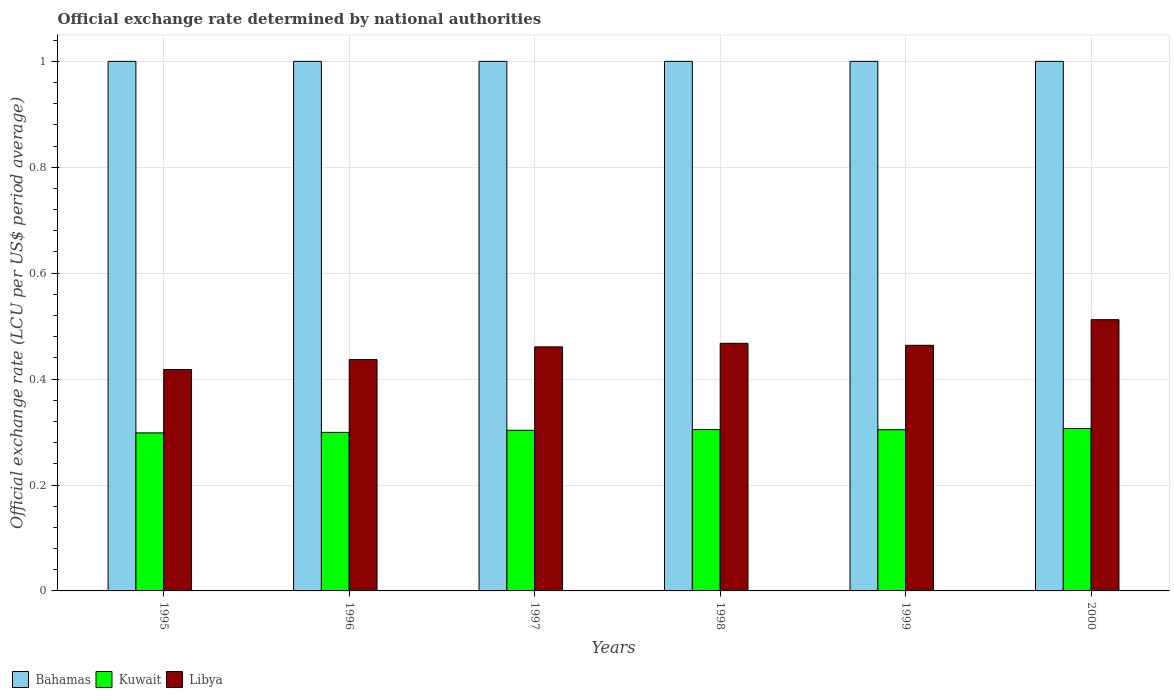Are the number of bars per tick equal to the number of legend labels?
Offer a terse response. Yes. Are the number of bars on each tick of the X-axis equal?
Give a very brief answer. Yes. How many bars are there on the 5th tick from the right?
Give a very brief answer. 3. What is the official exchange rate in Libya in 2000?
Provide a succinct answer. 0.51. Across all years, what is the minimum official exchange rate in Bahamas?
Your answer should be compact. 1. In which year was the official exchange rate in Libya maximum?
Offer a very short reply. 2000. What is the total official exchange rate in Libya in the graph?
Offer a very short reply. 2.76. What is the difference between the official exchange rate in Libya in 1995 and that in 1997?
Keep it short and to the point. -0.04. What is the difference between the official exchange rate in Bahamas in 1998 and the official exchange rate in Kuwait in 1995?
Your answer should be very brief. 0.7. What is the average official exchange rate in Kuwait per year?
Make the answer very short. 0.3. In the year 2000, what is the difference between the official exchange rate in Libya and official exchange rate in Bahamas?
Make the answer very short. -0.49. What is the ratio of the official exchange rate in Kuwait in 1998 to that in 1999?
Your response must be concise. 1. What is the difference between the highest and the second highest official exchange rate in Kuwait?
Offer a very short reply. 0. What is the difference between the highest and the lowest official exchange rate in Kuwait?
Provide a short and direct response. 0.01. Is the sum of the official exchange rate in Kuwait in 1997 and 2000 greater than the maximum official exchange rate in Bahamas across all years?
Provide a short and direct response. No. What does the 2nd bar from the left in 1995 represents?
Ensure brevity in your answer.  Kuwait. What does the 2nd bar from the right in 1995 represents?
Your response must be concise. Kuwait. Is it the case that in every year, the sum of the official exchange rate in Kuwait and official exchange rate in Libya is greater than the official exchange rate in Bahamas?
Your answer should be very brief. No. How many bars are there?
Your response must be concise. 18. Does the graph contain any zero values?
Your answer should be compact. No. How many legend labels are there?
Provide a short and direct response. 3. How are the legend labels stacked?
Your response must be concise. Horizontal. What is the title of the graph?
Your response must be concise. Official exchange rate determined by national authorities. Does "Gabon" appear as one of the legend labels in the graph?
Make the answer very short. No. What is the label or title of the X-axis?
Make the answer very short. Years. What is the label or title of the Y-axis?
Provide a short and direct response. Official exchange rate (LCU per US$ period average). What is the Official exchange rate (LCU per US$ period average) of Bahamas in 1995?
Provide a succinct answer. 1. What is the Official exchange rate (LCU per US$ period average) of Kuwait in 1995?
Ensure brevity in your answer.  0.3. What is the Official exchange rate (LCU per US$ period average) of Libya in 1995?
Give a very brief answer. 0.42. What is the Official exchange rate (LCU per US$ period average) of Bahamas in 1996?
Provide a short and direct response. 1. What is the Official exchange rate (LCU per US$ period average) of Kuwait in 1996?
Provide a succinct answer. 0.3. What is the Official exchange rate (LCU per US$ period average) in Libya in 1996?
Make the answer very short. 0.44. What is the Official exchange rate (LCU per US$ period average) in Bahamas in 1997?
Make the answer very short. 1. What is the Official exchange rate (LCU per US$ period average) of Kuwait in 1997?
Your answer should be very brief. 0.3. What is the Official exchange rate (LCU per US$ period average) in Libya in 1997?
Your answer should be compact. 0.46. What is the Official exchange rate (LCU per US$ period average) of Bahamas in 1998?
Offer a terse response. 1. What is the Official exchange rate (LCU per US$ period average) in Kuwait in 1998?
Provide a short and direct response. 0.3. What is the Official exchange rate (LCU per US$ period average) of Libya in 1998?
Provide a short and direct response. 0.47. What is the Official exchange rate (LCU per US$ period average) of Bahamas in 1999?
Provide a succinct answer. 1. What is the Official exchange rate (LCU per US$ period average) of Kuwait in 1999?
Your response must be concise. 0.3. What is the Official exchange rate (LCU per US$ period average) in Libya in 1999?
Keep it short and to the point. 0.46. What is the Official exchange rate (LCU per US$ period average) of Kuwait in 2000?
Provide a succinct answer. 0.31. What is the Official exchange rate (LCU per US$ period average) in Libya in 2000?
Make the answer very short. 0.51. Across all years, what is the maximum Official exchange rate (LCU per US$ period average) in Bahamas?
Keep it short and to the point. 1. Across all years, what is the maximum Official exchange rate (LCU per US$ period average) of Kuwait?
Your answer should be very brief. 0.31. Across all years, what is the maximum Official exchange rate (LCU per US$ period average) of Libya?
Your answer should be compact. 0.51. Across all years, what is the minimum Official exchange rate (LCU per US$ period average) of Kuwait?
Your response must be concise. 0.3. Across all years, what is the minimum Official exchange rate (LCU per US$ period average) in Libya?
Your answer should be compact. 0.42. What is the total Official exchange rate (LCU per US$ period average) in Kuwait in the graph?
Your response must be concise. 1.82. What is the total Official exchange rate (LCU per US$ period average) of Libya in the graph?
Provide a short and direct response. 2.76. What is the difference between the Official exchange rate (LCU per US$ period average) of Bahamas in 1995 and that in 1996?
Offer a terse response. 0. What is the difference between the Official exchange rate (LCU per US$ period average) in Kuwait in 1995 and that in 1996?
Offer a very short reply. -0. What is the difference between the Official exchange rate (LCU per US$ period average) in Libya in 1995 and that in 1996?
Your response must be concise. -0.02. What is the difference between the Official exchange rate (LCU per US$ period average) of Bahamas in 1995 and that in 1997?
Keep it short and to the point. 0. What is the difference between the Official exchange rate (LCU per US$ period average) of Kuwait in 1995 and that in 1997?
Offer a very short reply. -0. What is the difference between the Official exchange rate (LCU per US$ period average) of Libya in 1995 and that in 1997?
Make the answer very short. -0.04. What is the difference between the Official exchange rate (LCU per US$ period average) of Bahamas in 1995 and that in 1998?
Your response must be concise. 0. What is the difference between the Official exchange rate (LCU per US$ period average) of Kuwait in 1995 and that in 1998?
Ensure brevity in your answer.  -0.01. What is the difference between the Official exchange rate (LCU per US$ period average) in Libya in 1995 and that in 1998?
Make the answer very short. -0.05. What is the difference between the Official exchange rate (LCU per US$ period average) in Bahamas in 1995 and that in 1999?
Give a very brief answer. 0. What is the difference between the Official exchange rate (LCU per US$ period average) of Kuwait in 1995 and that in 1999?
Provide a short and direct response. -0.01. What is the difference between the Official exchange rate (LCU per US$ period average) of Libya in 1995 and that in 1999?
Ensure brevity in your answer.  -0.05. What is the difference between the Official exchange rate (LCU per US$ period average) in Bahamas in 1995 and that in 2000?
Provide a succinct answer. 0. What is the difference between the Official exchange rate (LCU per US$ period average) of Kuwait in 1995 and that in 2000?
Your answer should be compact. -0.01. What is the difference between the Official exchange rate (LCU per US$ period average) of Libya in 1995 and that in 2000?
Your response must be concise. -0.09. What is the difference between the Official exchange rate (LCU per US$ period average) of Bahamas in 1996 and that in 1997?
Offer a terse response. 0. What is the difference between the Official exchange rate (LCU per US$ period average) of Kuwait in 1996 and that in 1997?
Your response must be concise. -0. What is the difference between the Official exchange rate (LCU per US$ period average) in Libya in 1996 and that in 1997?
Give a very brief answer. -0.02. What is the difference between the Official exchange rate (LCU per US$ period average) in Bahamas in 1996 and that in 1998?
Give a very brief answer. 0. What is the difference between the Official exchange rate (LCU per US$ period average) of Kuwait in 1996 and that in 1998?
Your answer should be compact. -0.01. What is the difference between the Official exchange rate (LCU per US$ period average) of Libya in 1996 and that in 1998?
Provide a short and direct response. -0.03. What is the difference between the Official exchange rate (LCU per US$ period average) of Kuwait in 1996 and that in 1999?
Your answer should be very brief. -0.01. What is the difference between the Official exchange rate (LCU per US$ period average) in Libya in 1996 and that in 1999?
Keep it short and to the point. -0.03. What is the difference between the Official exchange rate (LCU per US$ period average) of Bahamas in 1996 and that in 2000?
Offer a terse response. 0. What is the difference between the Official exchange rate (LCU per US$ period average) of Kuwait in 1996 and that in 2000?
Ensure brevity in your answer.  -0.01. What is the difference between the Official exchange rate (LCU per US$ period average) of Libya in 1996 and that in 2000?
Provide a succinct answer. -0.08. What is the difference between the Official exchange rate (LCU per US$ period average) in Bahamas in 1997 and that in 1998?
Offer a terse response. 0. What is the difference between the Official exchange rate (LCU per US$ period average) of Kuwait in 1997 and that in 1998?
Ensure brevity in your answer.  -0. What is the difference between the Official exchange rate (LCU per US$ period average) in Libya in 1997 and that in 1998?
Your response must be concise. -0.01. What is the difference between the Official exchange rate (LCU per US$ period average) of Kuwait in 1997 and that in 1999?
Your response must be concise. -0. What is the difference between the Official exchange rate (LCU per US$ period average) of Libya in 1997 and that in 1999?
Your response must be concise. -0. What is the difference between the Official exchange rate (LCU per US$ period average) of Bahamas in 1997 and that in 2000?
Your response must be concise. 0. What is the difference between the Official exchange rate (LCU per US$ period average) of Kuwait in 1997 and that in 2000?
Ensure brevity in your answer.  -0. What is the difference between the Official exchange rate (LCU per US$ period average) of Libya in 1997 and that in 2000?
Provide a succinct answer. -0.05. What is the difference between the Official exchange rate (LCU per US$ period average) of Kuwait in 1998 and that in 1999?
Provide a short and direct response. 0. What is the difference between the Official exchange rate (LCU per US$ period average) of Libya in 1998 and that in 1999?
Offer a terse response. 0. What is the difference between the Official exchange rate (LCU per US$ period average) of Bahamas in 1998 and that in 2000?
Provide a short and direct response. 0. What is the difference between the Official exchange rate (LCU per US$ period average) in Kuwait in 1998 and that in 2000?
Your answer should be compact. -0. What is the difference between the Official exchange rate (LCU per US$ period average) in Libya in 1998 and that in 2000?
Offer a terse response. -0.04. What is the difference between the Official exchange rate (LCU per US$ period average) in Bahamas in 1999 and that in 2000?
Give a very brief answer. 0. What is the difference between the Official exchange rate (LCU per US$ period average) of Kuwait in 1999 and that in 2000?
Offer a very short reply. -0. What is the difference between the Official exchange rate (LCU per US$ period average) of Libya in 1999 and that in 2000?
Your answer should be very brief. -0.05. What is the difference between the Official exchange rate (LCU per US$ period average) of Bahamas in 1995 and the Official exchange rate (LCU per US$ period average) of Kuwait in 1996?
Provide a succinct answer. 0.7. What is the difference between the Official exchange rate (LCU per US$ period average) in Bahamas in 1995 and the Official exchange rate (LCU per US$ period average) in Libya in 1996?
Your response must be concise. 0.56. What is the difference between the Official exchange rate (LCU per US$ period average) of Kuwait in 1995 and the Official exchange rate (LCU per US$ period average) of Libya in 1996?
Your answer should be very brief. -0.14. What is the difference between the Official exchange rate (LCU per US$ period average) in Bahamas in 1995 and the Official exchange rate (LCU per US$ period average) in Kuwait in 1997?
Your answer should be compact. 0.7. What is the difference between the Official exchange rate (LCU per US$ period average) in Bahamas in 1995 and the Official exchange rate (LCU per US$ period average) in Libya in 1997?
Make the answer very short. 0.54. What is the difference between the Official exchange rate (LCU per US$ period average) of Kuwait in 1995 and the Official exchange rate (LCU per US$ period average) of Libya in 1997?
Provide a succinct answer. -0.16. What is the difference between the Official exchange rate (LCU per US$ period average) in Bahamas in 1995 and the Official exchange rate (LCU per US$ period average) in Kuwait in 1998?
Keep it short and to the point. 0.7. What is the difference between the Official exchange rate (LCU per US$ period average) of Bahamas in 1995 and the Official exchange rate (LCU per US$ period average) of Libya in 1998?
Provide a short and direct response. 0.53. What is the difference between the Official exchange rate (LCU per US$ period average) of Kuwait in 1995 and the Official exchange rate (LCU per US$ period average) of Libya in 1998?
Provide a short and direct response. -0.17. What is the difference between the Official exchange rate (LCU per US$ period average) of Bahamas in 1995 and the Official exchange rate (LCU per US$ period average) of Kuwait in 1999?
Provide a succinct answer. 0.7. What is the difference between the Official exchange rate (LCU per US$ period average) in Bahamas in 1995 and the Official exchange rate (LCU per US$ period average) in Libya in 1999?
Offer a very short reply. 0.54. What is the difference between the Official exchange rate (LCU per US$ period average) of Kuwait in 1995 and the Official exchange rate (LCU per US$ period average) of Libya in 1999?
Ensure brevity in your answer.  -0.17. What is the difference between the Official exchange rate (LCU per US$ period average) of Bahamas in 1995 and the Official exchange rate (LCU per US$ period average) of Kuwait in 2000?
Provide a short and direct response. 0.69. What is the difference between the Official exchange rate (LCU per US$ period average) of Bahamas in 1995 and the Official exchange rate (LCU per US$ period average) of Libya in 2000?
Give a very brief answer. 0.49. What is the difference between the Official exchange rate (LCU per US$ period average) in Kuwait in 1995 and the Official exchange rate (LCU per US$ period average) in Libya in 2000?
Provide a succinct answer. -0.21. What is the difference between the Official exchange rate (LCU per US$ period average) of Bahamas in 1996 and the Official exchange rate (LCU per US$ period average) of Kuwait in 1997?
Make the answer very short. 0.7. What is the difference between the Official exchange rate (LCU per US$ period average) of Bahamas in 1996 and the Official exchange rate (LCU per US$ period average) of Libya in 1997?
Offer a terse response. 0.54. What is the difference between the Official exchange rate (LCU per US$ period average) in Kuwait in 1996 and the Official exchange rate (LCU per US$ period average) in Libya in 1997?
Your answer should be compact. -0.16. What is the difference between the Official exchange rate (LCU per US$ period average) in Bahamas in 1996 and the Official exchange rate (LCU per US$ period average) in Kuwait in 1998?
Your response must be concise. 0.7. What is the difference between the Official exchange rate (LCU per US$ period average) of Bahamas in 1996 and the Official exchange rate (LCU per US$ period average) of Libya in 1998?
Provide a succinct answer. 0.53. What is the difference between the Official exchange rate (LCU per US$ period average) in Kuwait in 1996 and the Official exchange rate (LCU per US$ period average) in Libya in 1998?
Offer a terse response. -0.17. What is the difference between the Official exchange rate (LCU per US$ period average) in Bahamas in 1996 and the Official exchange rate (LCU per US$ period average) in Kuwait in 1999?
Provide a succinct answer. 0.7. What is the difference between the Official exchange rate (LCU per US$ period average) in Bahamas in 1996 and the Official exchange rate (LCU per US$ period average) in Libya in 1999?
Your response must be concise. 0.54. What is the difference between the Official exchange rate (LCU per US$ period average) in Kuwait in 1996 and the Official exchange rate (LCU per US$ period average) in Libya in 1999?
Keep it short and to the point. -0.16. What is the difference between the Official exchange rate (LCU per US$ period average) of Bahamas in 1996 and the Official exchange rate (LCU per US$ period average) of Kuwait in 2000?
Ensure brevity in your answer.  0.69. What is the difference between the Official exchange rate (LCU per US$ period average) in Bahamas in 1996 and the Official exchange rate (LCU per US$ period average) in Libya in 2000?
Provide a succinct answer. 0.49. What is the difference between the Official exchange rate (LCU per US$ period average) of Kuwait in 1996 and the Official exchange rate (LCU per US$ period average) of Libya in 2000?
Keep it short and to the point. -0.21. What is the difference between the Official exchange rate (LCU per US$ period average) of Bahamas in 1997 and the Official exchange rate (LCU per US$ period average) of Kuwait in 1998?
Ensure brevity in your answer.  0.7. What is the difference between the Official exchange rate (LCU per US$ period average) of Bahamas in 1997 and the Official exchange rate (LCU per US$ period average) of Libya in 1998?
Offer a terse response. 0.53. What is the difference between the Official exchange rate (LCU per US$ period average) of Kuwait in 1997 and the Official exchange rate (LCU per US$ period average) of Libya in 1998?
Provide a succinct answer. -0.16. What is the difference between the Official exchange rate (LCU per US$ period average) in Bahamas in 1997 and the Official exchange rate (LCU per US$ period average) in Kuwait in 1999?
Offer a very short reply. 0.7. What is the difference between the Official exchange rate (LCU per US$ period average) in Bahamas in 1997 and the Official exchange rate (LCU per US$ period average) in Libya in 1999?
Ensure brevity in your answer.  0.54. What is the difference between the Official exchange rate (LCU per US$ period average) of Kuwait in 1997 and the Official exchange rate (LCU per US$ period average) of Libya in 1999?
Your answer should be compact. -0.16. What is the difference between the Official exchange rate (LCU per US$ period average) of Bahamas in 1997 and the Official exchange rate (LCU per US$ period average) of Kuwait in 2000?
Give a very brief answer. 0.69. What is the difference between the Official exchange rate (LCU per US$ period average) of Bahamas in 1997 and the Official exchange rate (LCU per US$ period average) of Libya in 2000?
Provide a short and direct response. 0.49. What is the difference between the Official exchange rate (LCU per US$ period average) of Kuwait in 1997 and the Official exchange rate (LCU per US$ period average) of Libya in 2000?
Your response must be concise. -0.21. What is the difference between the Official exchange rate (LCU per US$ period average) of Bahamas in 1998 and the Official exchange rate (LCU per US$ period average) of Kuwait in 1999?
Your response must be concise. 0.7. What is the difference between the Official exchange rate (LCU per US$ period average) in Bahamas in 1998 and the Official exchange rate (LCU per US$ period average) in Libya in 1999?
Make the answer very short. 0.54. What is the difference between the Official exchange rate (LCU per US$ period average) of Kuwait in 1998 and the Official exchange rate (LCU per US$ period average) of Libya in 1999?
Your response must be concise. -0.16. What is the difference between the Official exchange rate (LCU per US$ period average) of Bahamas in 1998 and the Official exchange rate (LCU per US$ period average) of Kuwait in 2000?
Ensure brevity in your answer.  0.69. What is the difference between the Official exchange rate (LCU per US$ period average) of Bahamas in 1998 and the Official exchange rate (LCU per US$ period average) of Libya in 2000?
Provide a short and direct response. 0.49. What is the difference between the Official exchange rate (LCU per US$ period average) of Kuwait in 1998 and the Official exchange rate (LCU per US$ period average) of Libya in 2000?
Keep it short and to the point. -0.21. What is the difference between the Official exchange rate (LCU per US$ period average) in Bahamas in 1999 and the Official exchange rate (LCU per US$ period average) in Kuwait in 2000?
Provide a succinct answer. 0.69. What is the difference between the Official exchange rate (LCU per US$ period average) in Bahamas in 1999 and the Official exchange rate (LCU per US$ period average) in Libya in 2000?
Provide a short and direct response. 0.49. What is the difference between the Official exchange rate (LCU per US$ period average) of Kuwait in 1999 and the Official exchange rate (LCU per US$ period average) of Libya in 2000?
Give a very brief answer. -0.21. What is the average Official exchange rate (LCU per US$ period average) in Bahamas per year?
Provide a short and direct response. 1. What is the average Official exchange rate (LCU per US$ period average) in Kuwait per year?
Provide a succinct answer. 0.3. What is the average Official exchange rate (LCU per US$ period average) in Libya per year?
Your response must be concise. 0.46. In the year 1995, what is the difference between the Official exchange rate (LCU per US$ period average) in Bahamas and Official exchange rate (LCU per US$ period average) in Kuwait?
Offer a terse response. 0.7. In the year 1995, what is the difference between the Official exchange rate (LCU per US$ period average) of Bahamas and Official exchange rate (LCU per US$ period average) of Libya?
Your response must be concise. 0.58. In the year 1995, what is the difference between the Official exchange rate (LCU per US$ period average) of Kuwait and Official exchange rate (LCU per US$ period average) of Libya?
Keep it short and to the point. -0.12. In the year 1996, what is the difference between the Official exchange rate (LCU per US$ period average) of Bahamas and Official exchange rate (LCU per US$ period average) of Kuwait?
Make the answer very short. 0.7. In the year 1996, what is the difference between the Official exchange rate (LCU per US$ period average) of Bahamas and Official exchange rate (LCU per US$ period average) of Libya?
Offer a terse response. 0.56. In the year 1996, what is the difference between the Official exchange rate (LCU per US$ period average) in Kuwait and Official exchange rate (LCU per US$ period average) in Libya?
Give a very brief answer. -0.14. In the year 1997, what is the difference between the Official exchange rate (LCU per US$ period average) in Bahamas and Official exchange rate (LCU per US$ period average) in Kuwait?
Provide a short and direct response. 0.7. In the year 1997, what is the difference between the Official exchange rate (LCU per US$ period average) of Bahamas and Official exchange rate (LCU per US$ period average) of Libya?
Offer a terse response. 0.54. In the year 1997, what is the difference between the Official exchange rate (LCU per US$ period average) of Kuwait and Official exchange rate (LCU per US$ period average) of Libya?
Offer a very short reply. -0.16. In the year 1998, what is the difference between the Official exchange rate (LCU per US$ period average) of Bahamas and Official exchange rate (LCU per US$ period average) of Kuwait?
Ensure brevity in your answer.  0.7. In the year 1998, what is the difference between the Official exchange rate (LCU per US$ period average) in Bahamas and Official exchange rate (LCU per US$ period average) in Libya?
Your answer should be very brief. 0.53. In the year 1998, what is the difference between the Official exchange rate (LCU per US$ period average) in Kuwait and Official exchange rate (LCU per US$ period average) in Libya?
Your answer should be compact. -0.16. In the year 1999, what is the difference between the Official exchange rate (LCU per US$ period average) of Bahamas and Official exchange rate (LCU per US$ period average) of Kuwait?
Give a very brief answer. 0.7. In the year 1999, what is the difference between the Official exchange rate (LCU per US$ period average) of Bahamas and Official exchange rate (LCU per US$ period average) of Libya?
Your response must be concise. 0.54. In the year 1999, what is the difference between the Official exchange rate (LCU per US$ period average) of Kuwait and Official exchange rate (LCU per US$ period average) of Libya?
Ensure brevity in your answer.  -0.16. In the year 2000, what is the difference between the Official exchange rate (LCU per US$ period average) in Bahamas and Official exchange rate (LCU per US$ period average) in Kuwait?
Your response must be concise. 0.69. In the year 2000, what is the difference between the Official exchange rate (LCU per US$ period average) in Bahamas and Official exchange rate (LCU per US$ period average) in Libya?
Your response must be concise. 0.49. In the year 2000, what is the difference between the Official exchange rate (LCU per US$ period average) in Kuwait and Official exchange rate (LCU per US$ period average) in Libya?
Provide a succinct answer. -0.21. What is the ratio of the Official exchange rate (LCU per US$ period average) in Kuwait in 1995 to that in 1996?
Keep it short and to the point. 1. What is the ratio of the Official exchange rate (LCU per US$ period average) of Libya in 1995 to that in 1996?
Ensure brevity in your answer.  0.96. What is the ratio of the Official exchange rate (LCU per US$ period average) in Kuwait in 1995 to that in 1997?
Your answer should be very brief. 0.98. What is the ratio of the Official exchange rate (LCU per US$ period average) of Libya in 1995 to that in 1997?
Offer a terse response. 0.91. What is the ratio of the Official exchange rate (LCU per US$ period average) in Kuwait in 1995 to that in 1998?
Offer a very short reply. 0.98. What is the ratio of the Official exchange rate (LCU per US$ period average) of Libya in 1995 to that in 1998?
Give a very brief answer. 0.89. What is the ratio of the Official exchange rate (LCU per US$ period average) of Bahamas in 1995 to that in 1999?
Your response must be concise. 1. What is the ratio of the Official exchange rate (LCU per US$ period average) of Kuwait in 1995 to that in 1999?
Provide a short and direct response. 0.98. What is the ratio of the Official exchange rate (LCU per US$ period average) in Libya in 1995 to that in 1999?
Offer a very short reply. 0.9. What is the ratio of the Official exchange rate (LCU per US$ period average) in Kuwait in 1995 to that in 2000?
Ensure brevity in your answer.  0.97. What is the ratio of the Official exchange rate (LCU per US$ period average) of Libya in 1995 to that in 2000?
Offer a very short reply. 0.82. What is the ratio of the Official exchange rate (LCU per US$ period average) of Bahamas in 1996 to that in 1997?
Your answer should be very brief. 1. What is the ratio of the Official exchange rate (LCU per US$ period average) of Libya in 1996 to that in 1997?
Keep it short and to the point. 0.95. What is the ratio of the Official exchange rate (LCU per US$ period average) of Bahamas in 1996 to that in 1998?
Keep it short and to the point. 1. What is the ratio of the Official exchange rate (LCU per US$ period average) of Kuwait in 1996 to that in 1998?
Your response must be concise. 0.98. What is the ratio of the Official exchange rate (LCU per US$ period average) of Libya in 1996 to that in 1998?
Provide a succinct answer. 0.93. What is the ratio of the Official exchange rate (LCU per US$ period average) in Kuwait in 1996 to that in 1999?
Ensure brevity in your answer.  0.98. What is the ratio of the Official exchange rate (LCU per US$ period average) of Libya in 1996 to that in 1999?
Ensure brevity in your answer.  0.94. What is the ratio of the Official exchange rate (LCU per US$ period average) in Kuwait in 1996 to that in 2000?
Ensure brevity in your answer.  0.98. What is the ratio of the Official exchange rate (LCU per US$ period average) of Libya in 1996 to that in 2000?
Keep it short and to the point. 0.85. What is the ratio of the Official exchange rate (LCU per US$ period average) in Kuwait in 1997 to that in 1998?
Offer a terse response. 1. What is the ratio of the Official exchange rate (LCU per US$ period average) in Libya in 1997 to that in 1998?
Make the answer very short. 0.99. What is the ratio of the Official exchange rate (LCU per US$ period average) of Bahamas in 1997 to that in 1999?
Your answer should be very brief. 1. What is the ratio of the Official exchange rate (LCU per US$ period average) in Libya in 1997 to that in 1999?
Your answer should be very brief. 0.99. What is the ratio of the Official exchange rate (LCU per US$ period average) in Bahamas in 1997 to that in 2000?
Ensure brevity in your answer.  1. What is the ratio of the Official exchange rate (LCU per US$ period average) in Kuwait in 1997 to that in 2000?
Your answer should be very brief. 0.99. What is the ratio of the Official exchange rate (LCU per US$ period average) in Libya in 1997 to that in 2000?
Offer a terse response. 0.9. What is the ratio of the Official exchange rate (LCU per US$ period average) of Bahamas in 1998 to that in 1999?
Give a very brief answer. 1. What is the ratio of the Official exchange rate (LCU per US$ period average) in Libya in 1998 to that in 1999?
Make the answer very short. 1.01. What is the ratio of the Official exchange rate (LCU per US$ period average) of Bahamas in 1998 to that in 2000?
Offer a terse response. 1. What is the ratio of the Official exchange rate (LCU per US$ period average) of Kuwait in 1998 to that in 2000?
Make the answer very short. 0.99. What is the ratio of the Official exchange rate (LCU per US$ period average) in Libya in 1998 to that in 2000?
Make the answer very short. 0.91. What is the ratio of the Official exchange rate (LCU per US$ period average) of Kuwait in 1999 to that in 2000?
Ensure brevity in your answer.  0.99. What is the ratio of the Official exchange rate (LCU per US$ period average) in Libya in 1999 to that in 2000?
Keep it short and to the point. 0.91. What is the difference between the highest and the second highest Official exchange rate (LCU per US$ period average) in Kuwait?
Ensure brevity in your answer.  0. What is the difference between the highest and the second highest Official exchange rate (LCU per US$ period average) of Libya?
Provide a short and direct response. 0.04. What is the difference between the highest and the lowest Official exchange rate (LCU per US$ period average) in Kuwait?
Provide a short and direct response. 0.01. What is the difference between the highest and the lowest Official exchange rate (LCU per US$ period average) in Libya?
Offer a very short reply. 0.09. 